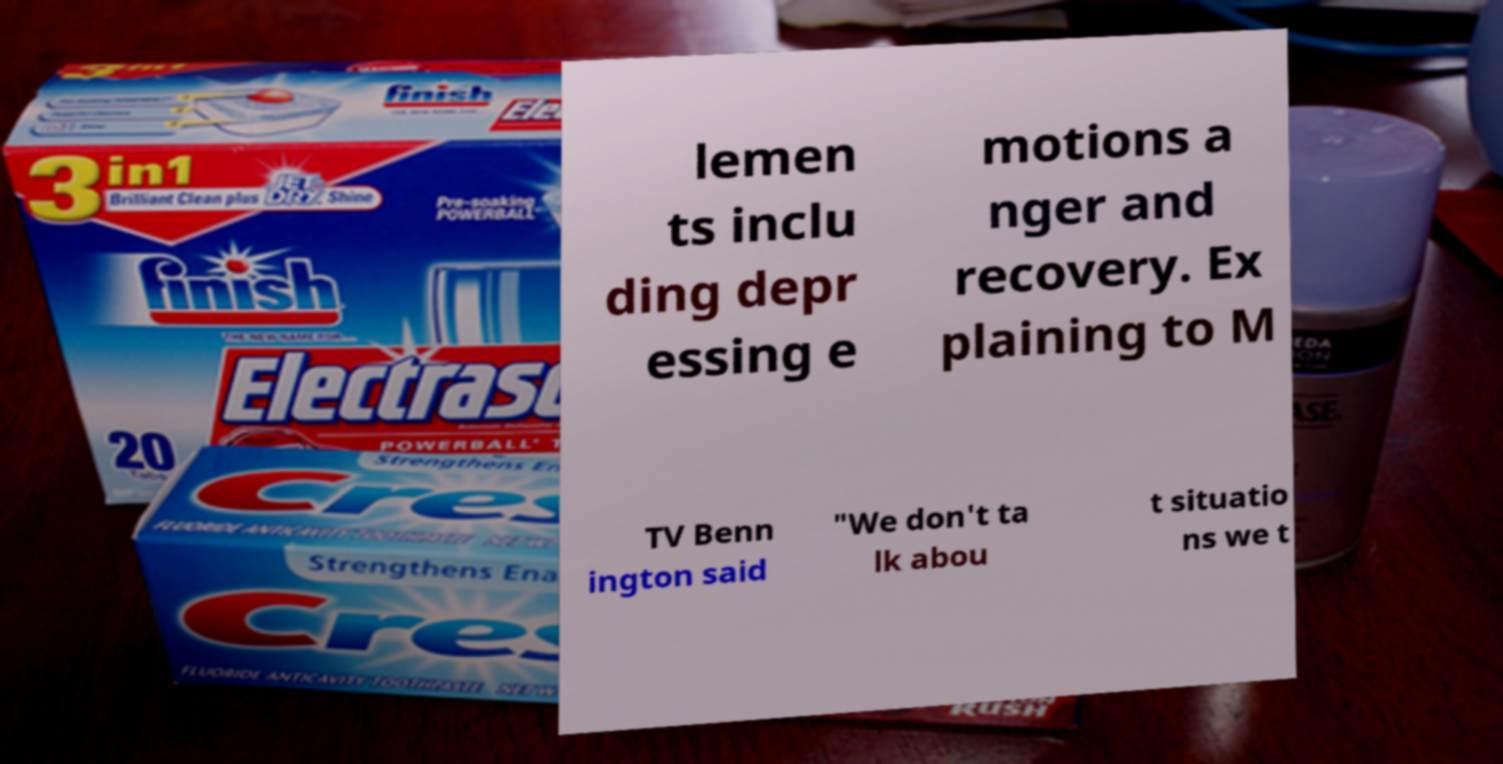Could you extract and type out the text from this image? lemen ts inclu ding depr essing e motions a nger and recovery. Ex plaining to M TV Benn ington said "We don't ta lk abou t situatio ns we t 